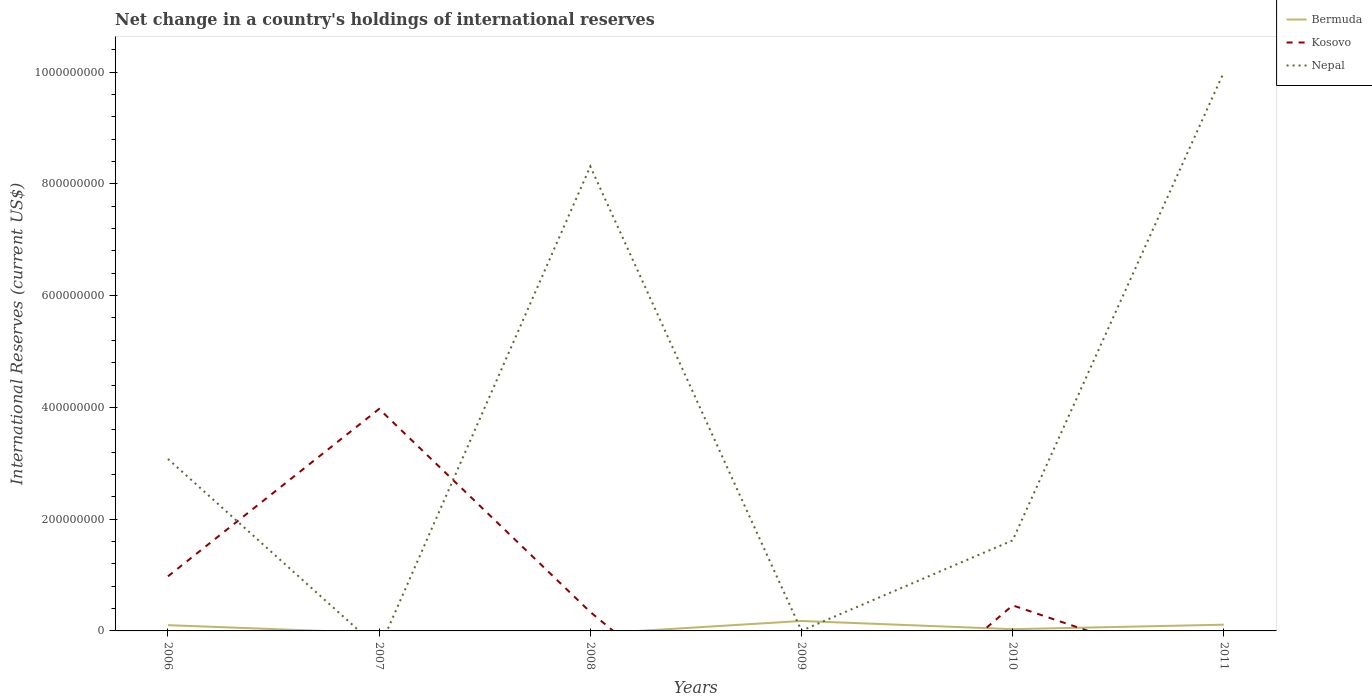How many different coloured lines are there?
Your answer should be very brief. 3. Does the line corresponding to Kosovo intersect with the line corresponding to Nepal?
Ensure brevity in your answer.  Yes. Across all years, what is the maximum international reserves in Bermuda?
Your answer should be very brief. 0. What is the total international reserves in Nepal in the graph?
Keep it short and to the point. 6.69e+08. What is the difference between the highest and the second highest international reserves in Bermuda?
Give a very brief answer. 1.78e+07. What is the difference between the highest and the lowest international reserves in Bermuda?
Offer a terse response. 3. Is the international reserves in Bermuda strictly greater than the international reserves in Kosovo over the years?
Keep it short and to the point. No. How many lines are there?
Ensure brevity in your answer.  3. How many years are there in the graph?
Your answer should be compact. 6. Are the values on the major ticks of Y-axis written in scientific E-notation?
Provide a succinct answer. No. Does the graph contain any zero values?
Keep it short and to the point. Yes. What is the title of the graph?
Your answer should be compact. Net change in a country's holdings of international reserves. Does "Congo (Republic)" appear as one of the legend labels in the graph?
Offer a very short reply. No. What is the label or title of the X-axis?
Ensure brevity in your answer.  Years. What is the label or title of the Y-axis?
Keep it short and to the point. International Reserves (current US$). What is the International Reserves (current US$) of Bermuda in 2006?
Ensure brevity in your answer.  1.03e+07. What is the International Reserves (current US$) of Kosovo in 2006?
Your answer should be compact. 9.77e+07. What is the International Reserves (current US$) in Nepal in 2006?
Make the answer very short. 3.08e+08. What is the International Reserves (current US$) in Kosovo in 2007?
Give a very brief answer. 3.97e+08. What is the International Reserves (current US$) in Bermuda in 2008?
Ensure brevity in your answer.  0. What is the International Reserves (current US$) of Kosovo in 2008?
Provide a short and direct response. 3.38e+07. What is the International Reserves (current US$) of Nepal in 2008?
Offer a very short reply. 8.31e+08. What is the International Reserves (current US$) of Bermuda in 2009?
Offer a terse response. 1.78e+07. What is the International Reserves (current US$) of Nepal in 2009?
Give a very brief answer. 3.94e+05. What is the International Reserves (current US$) of Bermuda in 2010?
Give a very brief answer. 3.14e+06. What is the International Reserves (current US$) of Kosovo in 2010?
Ensure brevity in your answer.  4.57e+07. What is the International Reserves (current US$) in Nepal in 2010?
Your response must be concise. 1.62e+08. What is the International Reserves (current US$) of Bermuda in 2011?
Your answer should be compact. 1.12e+07. What is the International Reserves (current US$) in Kosovo in 2011?
Keep it short and to the point. 0. What is the International Reserves (current US$) of Nepal in 2011?
Your answer should be very brief. 1.00e+09. Across all years, what is the maximum International Reserves (current US$) of Bermuda?
Keep it short and to the point. 1.78e+07. Across all years, what is the maximum International Reserves (current US$) in Kosovo?
Your response must be concise. 3.97e+08. Across all years, what is the maximum International Reserves (current US$) in Nepal?
Give a very brief answer. 1.00e+09. Across all years, what is the minimum International Reserves (current US$) of Bermuda?
Make the answer very short. 0. Across all years, what is the minimum International Reserves (current US$) of Nepal?
Provide a short and direct response. 0. What is the total International Reserves (current US$) in Bermuda in the graph?
Your answer should be compact. 4.24e+07. What is the total International Reserves (current US$) of Kosovo in the graph?
Give a very brief answer. 5.75e+08. What is the total International Reserves (current US$) in Nepal in the graph?
Ensure brevity in your answer.  2.30e+09. What is the difference between the International Reserves (current US$) of Kosovo in 2006 and that in 2007?
Ensure brevity in your answer.  -3.00e+08. What is the difference between the International Reserves (current US$) of Kosovo in 2006 and that in 2008?
Your answer should be compact. 6.39e+07. What is the difference between the International Reserves (current US$) in Nepal in 2006 and that in 2008?
Give a very brief answer. -5.23e+08. What is the difference between the International Reserves (current US$) of Bermuda in 2006 and that in 2009?
Keep it short and to the point. -7.51e+06. What is the difference between the International Reserves (current US$) of Nepal in 2006 and that in 2009?
Give a very brief answer. 3.07e+08. What is the difference between the International Reserves (current US$) of Bermuda in 2006 and that in 2010?
Ensure brevity in your answer.  7.16e+06. What is the difference between the International Reserves (current US$) of Kosovo in 2006 and that in 2010?
Provide a succinct answer. 5.20e+07. What is the difference between the International Reserves (current US$) of Nepal in 2006 and that in 2010?
Keep it short and to the point. 1.46e+08. What is the difference between the International Reserves (current US$) in Bermuda in 2006 and that in 2011?
Provide a succinct answer. -8.52e+05. What is the difference between the International Reserves (current US$) of Nepal in 2006 and that in 2011?
Provide a succinct answer. -6.92e+08. What is the difference between the International Reserves (current US$) in Kosovo in 2007 and that in 2008?
Offer a very short reply. 3.63e+08. What is the difference between the International Reserves (current US$) of Kosovo in 2007 and that in 2010?
Provide a succinct answer. 3.52e+08. What is the difference between the International Reserves (current US$) in Nepal in 2008 and that in 2009?
Make the answer very short. 8.31e+08. What is the difference between the International Reserves (current US$) of Kosovo in 2008 and that in 2010?
Your answer should be compact. -1.19e+07. What is the difference between the International Reserves (current US$) of Nepal in 2008 and that in 2010?
Offer a very short reply. 6.69e+08. What is the difference between the International Reserves (current US$) in Nepal in 2008 and that in 2011?
Make the answer very short. -1.69e+08. What is the difference between the International Reserves (current US$) in Bermuda in 2009 and that in 2010?
Your answer should be very brief. 1.47e+07. What is the difference between the International Reserves (current US$) in Nepal in 2009 and that in 2010?
Give a very brief answer. -1.62e+08. What is the difference between the International Reserves (current US$) of Bermuda in 2009 and that in 2011?
Offer a terse response. 6.66e+06. What is the difference between the International Reserves (current US$) in Nepal in 2009 and that in 2011?
Offer a terse response. -9.99e+08. What is the difference between the International Reserves (current US$) of Bermuda in 2010 and that in 2011?
Ensure brevity in your answer.  -8.01e+06. What is the difference between the International Reserves (current US$) of Nepal in 2010 and that in 2011?
Make the answer very short. -8.38e+08. What is the difference between the International Reserves (current US$) in Bermuda in 2006 and the International Reserves (current US$) in Kosovo in 2007?
Offer a terse response. -3.87e+08. What is the difference between the International Reserves (current US$) in Bermuda in 2006 and the International Reserves (current US$) in Kosovo in 2008?
Keep it short and to the point. -2.35e+07. What is the difference between the International Reserves (current US$) of Bermuda in 2006 and the International Reserves (current US$) of Nepal in 2008?
Offer a very short reply. -8.21e+08. What is the difference between the International Reserves (current US$) of Kosovo in 2006 and the International Reserves (current US$) of Nepal in 2008?
Provide a short and direct response. -7.33e+08. What is the difference between the International Reserves (current US$) of Bermuda in 2006 and the International Reserves (current US$) of Nepal in 2009?
Give a very brief answer. 9.91e+06. What is the difference between the International Reserves (current US$) of Kosovo in 2006 and the International Reserves (current US$) of Nepal in 2009?
Make the answer very short. 9.73e+07. What is the difference between the International Reserves (current US$) of Bermuda in 2006 and the International Reserves (current US$) of Kosovo in 2010?
Keep it short and to the point. -3.54e+07. What is the difference between the International Reserves (current US$) in Bermuda in 2006 and the International Reserves (current US$) in Nepal in 2010?
Provide a short and direct response. -1.52e+08. What is the difference between the International Reserves (current US$) in Kosovo in 2006 and the International Reserves (current US$) in Nepal in 2010?
Make the answer very short. -6.43e+07. What is the difference between the International Reserves (current US$) in Bermuda in 2006 and the International Reserves (current US$) in Nepal in 2011?
Provide a short and direct response. -9.89e+08. What is the difference between the International Reserves (current US$) in Kosovo in 2006 and the International Reserves (current US$) in Nepal in 2011?
Make the answer very short. -9.02e+08. What is the difference between the International Reserves (current US$) of Kosovo in 2007 and the International Reserves (current US$) of Nepal in 2008?
Your answer should be very brief. -4.34e+08. What is the difference between the International Reserves (current US$) of Kosovo in 2007 and the International Reserves (current US$) of Nepal in 2009?
Your answer should be very brief. 3.97e+08. What is the difference between the International Reserves (current US$) of Kosovo in 2007 and the International Reserves (current US$) of Nepal in 2010?
Your response must be concise. 2.35e+08. What is the difference between the International Reserves (current US$) in Kosovo in 2007 and the International Reserves (current US$) in Nepal in 2011?
Your answer should be compact. -6.02e+08. What is the difference between the International Reserves (current US$) of Kosovo in 2008 and the International Reserves (current US$) of Nepal in 2009?
Your answer should be compact. 3.34e+07. What is the difference between the International Reserves (current US$) of Kosovo in 2008 and the International Reserves (current US$) of Nepal in 2010?
Your response must be concise. -1.28e+08. What is the difference between the International Reserves (current US$) in Kosovo in 2008 and the International Reserves (current US$) in Nepal in 2011?
Provide a short and direct response. -9.66e+08. What is the difference between the International Reserves (current US$) of Bermuda in 2009 and the International Reserves (current US$) of Kosovo in 2010?
Offer a very short reply. -2.79e+07. What is the difference between the International Reserves (current US$) of Bermuda in 2009 and the International Reserves (current US$) of Nepal in 2010?
Your answer should be very brief. -1.44e+08. What is the difference between the International Reserves (current US$) in Bermuda in 2009 and the International Reserves (current US$) in Nepal in 2011?
Keep it short and to the point. -9.82e+08. What is the difference between the International Reserves (current US$) of Bermuda in 2010 and the International Reserves (current US$) of Nepal in 2011?
Make the answer very short. -9.97e+08. What is the difference between the International Reserves (current US$) in Kosovo in 2010 and the International Reserves (current US$) in Nepal in 2011?
Offer a terse response. -9.54e+08. What is the average International Reserves (current US$) of Bermuda per year?
Give a very brief answer. 7.07e+06. What is the average International Reserves (current US$) of Kosovo per year?
Your answer should be compact. 9.58e+07. What is the average International Reserves (current US$) in Nepal per year?
Provide a short and direct response. 3.83e+08. In the year 2006, what is the difference between the International Reserves (current US$) in Bermuda and International Reserves (current US$) in Kosovo?
Make the answer very short. -8.74e+07. In the year 2006, what is the difference between the International Reserves (current US$) of Bermuda and International Reserves (current US$) of Nepal?
Ensure brevity in your answer.  -2.97e+08. In the year 2006, what is the difference between the International Reserves (current US$) in Kosovo and International Reserves (current US$) in Nepal?
Offer a terse response. -2.10e+08. In the year 2008, what is the difference between the International Reserves (current US$) of Kosovo and International Reserves (current US$) of Nepal?
Give a very brief answer. -7.97e+08. In the year 2009, what is the difference between the International Reserves (current US$) of Bermuda and International Reserves (current US$) of Nepal?
Ensure brevity in your answer.  1.74e+07. In the year 2010, what is the difference between the International Reserves (current US$) of Bermuda and International Reserves (current US$) of Kosovo?
Make the answer very short. -4.26e+07. In the year 2010, what is the difference between the International Reserves (current US$) in Bermuda and International Reserves (current US$) in Nepal?
Your answer should be very brief. -1.59e+08. In the year 2010, what is the difference between the International Reserves (current US$) in Kosovo and International Reserves (current US$) in Nepal?
Keep it short and to the point. -1.16e+08. In the year 2011, what is the difference between the International Reserves (current US$) in Bermuda and International Reserves (current US$) in Nepal?
Provide a succinct answer. -9.89e+08. What is the ratio of the International Reserves (current US$) of Kosovo in 2006 to that in 2007?
Provide a short and direct response. 0.25. What is the ratio of the International Reserves (current US$) of Kosovo in 2006 to that in 2008?
Make the answer very short. 2.89. What is the ratio of the International Reserves (current US$) of Nepal in 2006 to that in 2008?
Provide a short and direct response. 0.37. What is the ratio of the International Reserves (current US$) in Bermuda in 2006 to that in 2009?
Provide a short and direct response. 0.58. What is the ratio of the International Reserves (current US$) in Nepal in 2006 to that in 2009?
Your answer should be compact. 781.18. What is the ratio of the International Reserves (current US$) of Bermuda in 2006 to that in 2010?
Your response must be concise. 3.28. What is the ratio of the International Reserves (current US$) in Kosovo in 2006 to that in 2010?
Provide a short and direct response. 2.14. What is the ratio of the International Reserves (current US$) of Nepal in 2006 to that in 2010?
Your answer should be very brief. 1.9. What is the ratio of the International Reserves (current US$) of Bermuda in 2006 to that in 2011?
Offer a very short reply. 0.92. What is the ratio of the International Reserves (current US$) of Nepal in 2006 to that in 2011?
Provide a succinct answer. 0.31. What is the ratio of the International Reserves (current US$) in Kosovo in 2007 to that in 2008?
Ensure brevity in your answer.  11.75. What is the ratio of the International Reserves (current US$) in Kosovo in 2007 to that in 2010?
Make the answer very short. 8.69. What is the ratio of the International Reserves (current US$) in Nepal in 2008 to that in 2009?
Provide a short and direct response. 2109.94. What is the ratio of the International Reserves (current US$) in Kosovo in 2008 to that in 2010?
Your response must be concise. 0.74. What is the ratio of the International Reserves (current US$) of Nepal in 2008 to that in 2010?
Offer a terse response. 5.13. What is the ratio of the International Reserves (current US$) in Nepal in 2008 to that in 2011?
Your answer should be compact. 0.83. What is the ratio of the International Reserves (current US$) in Bermuda in 2009 to that in 2010?
Keep it short and to the point. 5.67. What is the ratio of the International Reserves (current US$) in Nepal in 2009 to that in 2010?
Your answer should be very brief. 0. What is the ratio of the International Reserves (current US$) of Bermuda in 2009 to that in 2011?
Offer a terse response. 1.6. What is the ratio of the International Reserves (current US$) in Bermuda in 2010 to that in 2011?
Offer a terse response. 0.28. What is the ratio of the International Reserves (current US$) in Nepal in 2010 to that in 2011?
Your answer should be very brief. 0.16. What is the difference between the highest and the second highest International Reserves (current US$) in Bermuda?
Offer a very short reply. 6.66e+06. What is the difference between the highest and the second highest International Reserves (current US$) of Kosovo?
Your answer should be very brief. 3.00e+08. What is the difference between the highest and the second highest International Reserves (current US$) of Nepal?
Provide a short and direct response. 1.69e+08. What is the difference between the highest and the lowest International Reserves (current US$) in Bermuda?
Your answer should be compact. 1.78e+07. What is the difference between the highest and the lowest International Reserves (current US$) in Kosovo?
Your answer should be compact. 3.97e+08. What is the difference between the highest and the lowest International Reserves (current US$) in Nepal?
Your answer should be compact. 1.00e+09. 